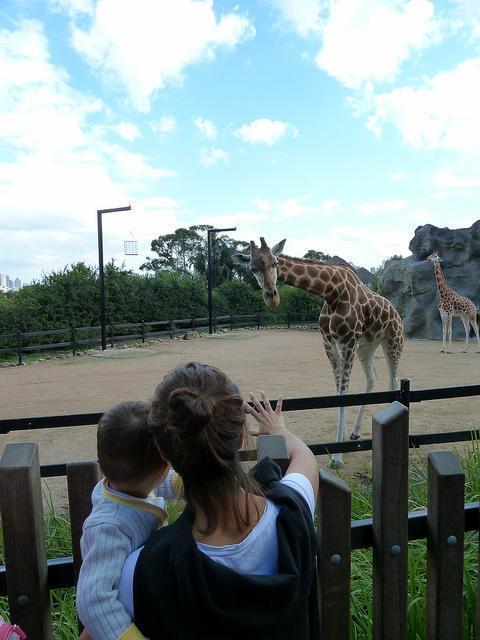How many people are there?
Give a very brief answer. 2. 